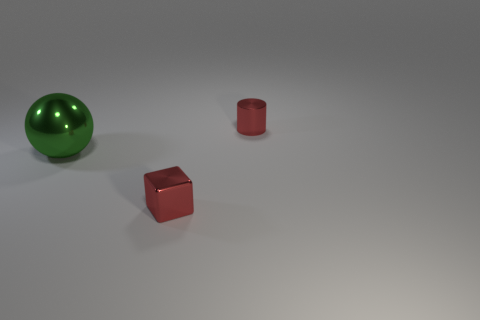What shape is the thing that is the same color as the shiny cylinder?
Provide a succinct answer. Cube. There is a block that is the same color as the small metallic cylinder; what is its size?
Make the answer very short. Small. There is a red metal object that is behind the large green metal object; what size is it?
Your answer should be compact. Small. Are there any other things that are the same size as the green thing?
Your answer should be very brief. No. What color is the shiny thing that is both right of the big sphere and behind the tiny red shiny cube?
Your response must be concise. Red. Does the red object that is to the right of the red shiny block have the same material as the green object?
Offer a terse response. Yes. There is a metal block; is its color the same as the small object that is behind the green shiny sphere?
Provide a succinct answer. Yes. There is a green metallic thing; are there any balls right of it?
Provide a short and direct response. No. There is a red metallic object that is in front of the green object; does it have the same size as the red metallic object that is behind the large green thing?
Your answer should be compact. Yes. Is there a red cylinder of the same size as the red cube?
Your response must be concise. Yes. 